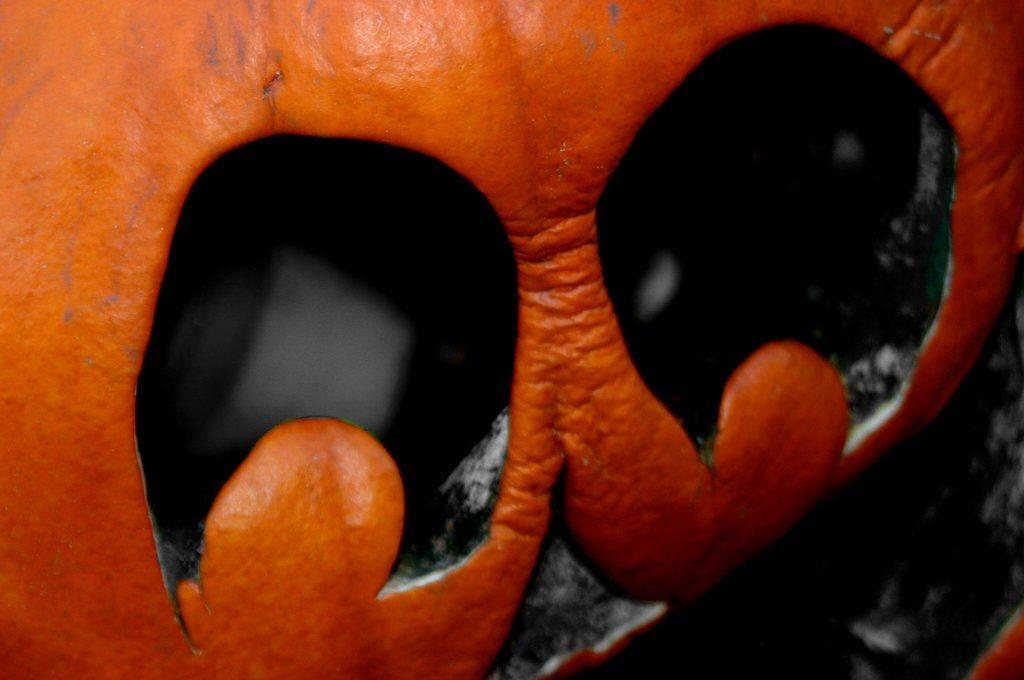How would you summarize this image in a sentence or two? In this picture it looks like an orange peel in the front, there is a dark background. 